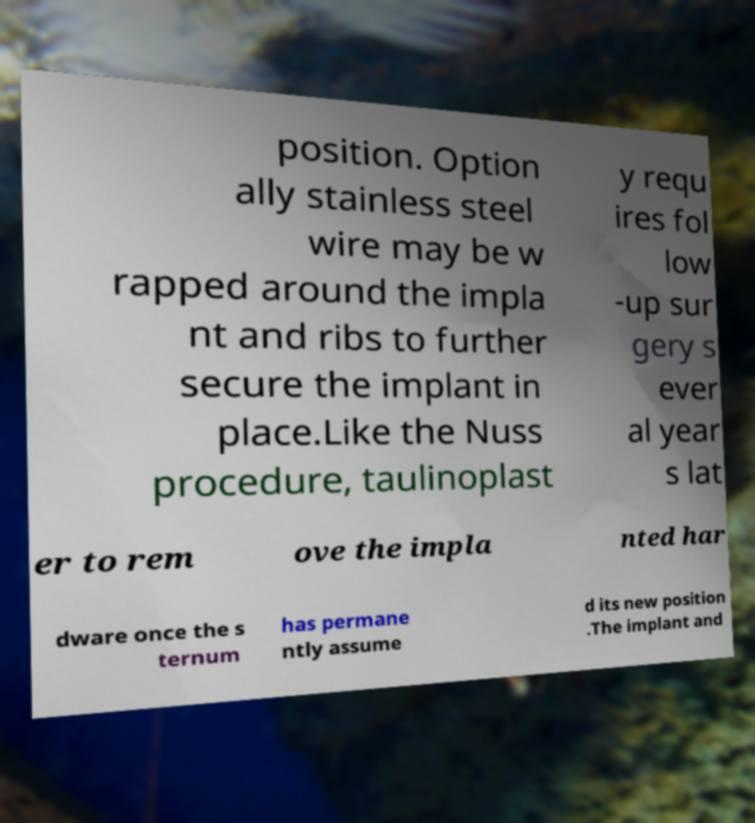Could you extract and type out the text from this image? position. Option ally stainless steel wire may be w rapped around the impla nt and ribs to further secure the implant in place.Like the Nuss procedure, taulinoplast y requ ires fol low -up sur gery s ever al year s lat er to rem ove the impla nted har dware once the s ternum has permane ntly assume d its new position .The implant and 